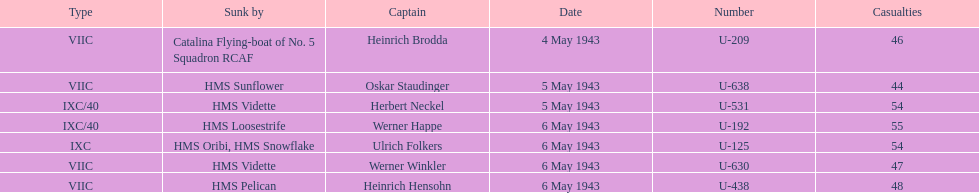How many captains are listed? 7. 